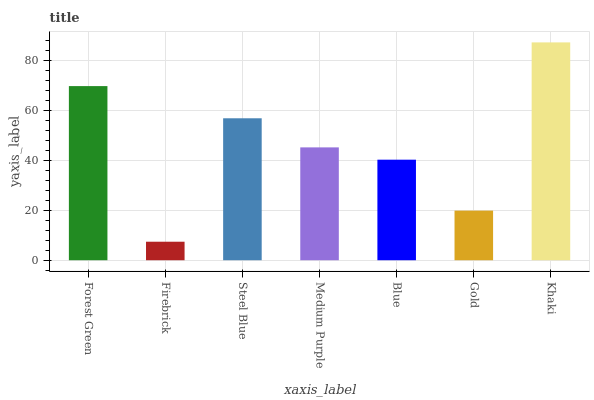Is Firebrick the minimum?
Answer yes or no. Yes. Is Khaki the maximum?
Answer yes or no. Yes. Is Steel Blue the minimum?
Answer yes or no. No. Is Steel Blue the maximum?
Answer yes or no. No. Is Steel Blue greater than Firebrick?
Answer yes or no. Yes. Is Firebrick less than Steel Blue?
Answer yes or no. Yes. Is Firebrick greater than Steel Blue?
Answer yes or no. No. Is Steel Blue less than Firebrick?
Answer yes or no. No. Is Medium Purple the high median?
Answer yes or no. Yes. Is Medium Purple the low median?
Answer yes or no. Yes. Is Khaki the high median?
Answer yes or no. No. Is Khaki the low median?
Answer yes or no. No. 